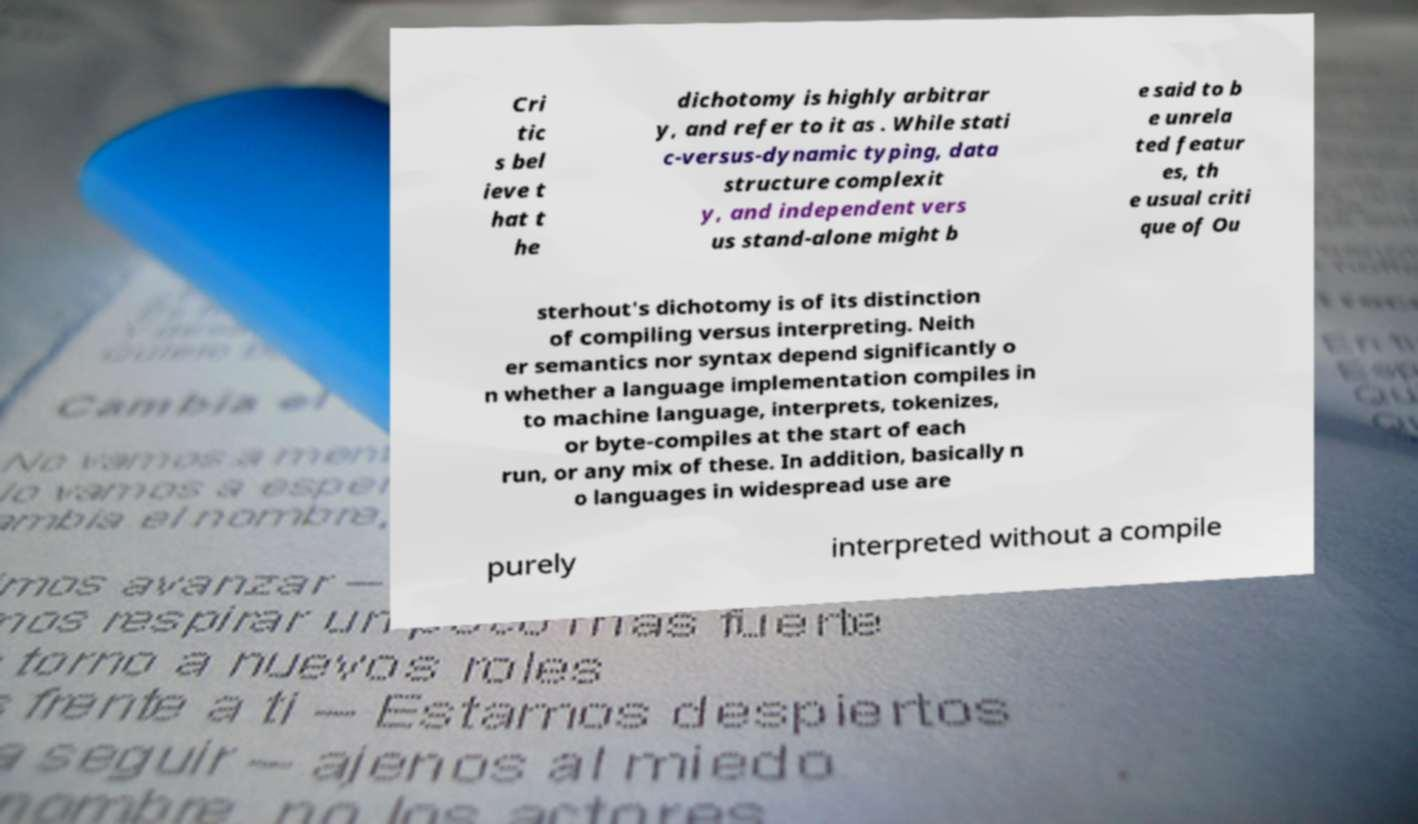Could you extract and type out the text from this image? Cri tic s bel ieve t hat t he dichotomy is highly arbitrar y, and refer to it as . While stati c-versus-dynamic typing, data structure complexit y, and independent vers us stand-alone might b e said to b e unrela ted featur es, th e usual criti que of Ou sterhout's dichotomy is of its distinction of compiling versus interpreting. Neith er semantics nor syntax depend significantly o n whether a language implementation compiles in to machine language, interprets, tokenizes, or byte-compiles at the start of each run, or any mix of these. In addition, basically n o languages in widespread use are purely interpreted without a compile 